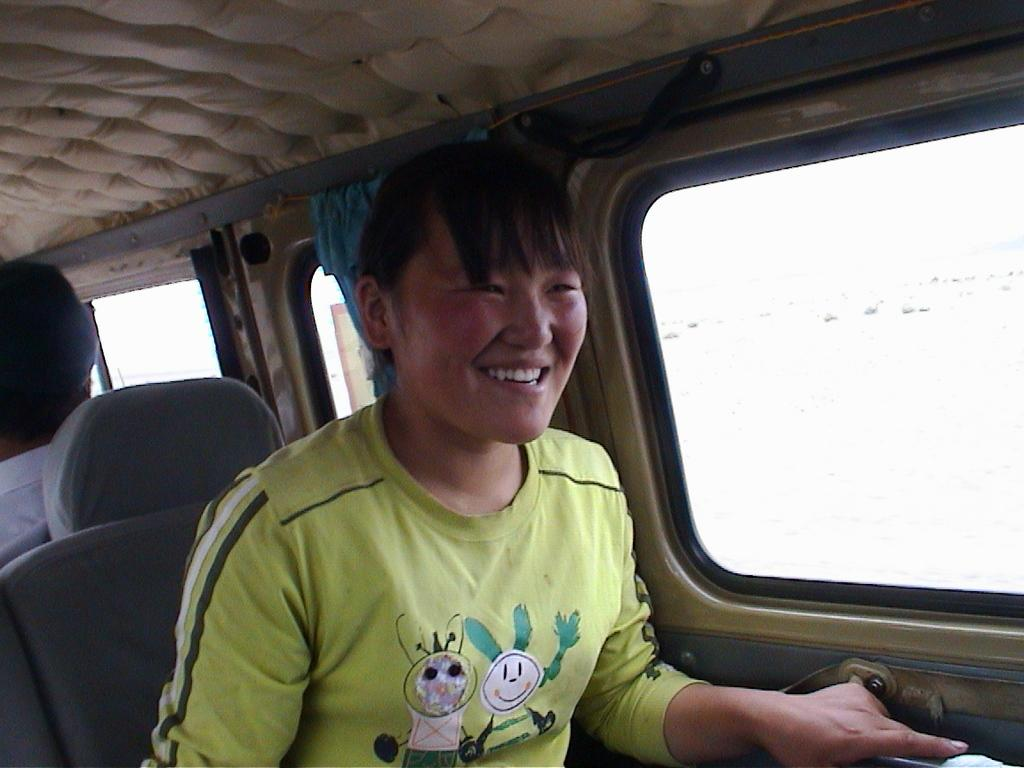Who or what can be seen in the image? There are people in the image. What are the people doing in the image? The people are sitting in a vehicle. How many clocks are visible in the image? There are no clocks visible in the image; it features people sitting in a vehicle. What type of pencil can be seen being used by the people in the image? There is no pencil present in the image, as it only shows people sitting in a vehicle. 